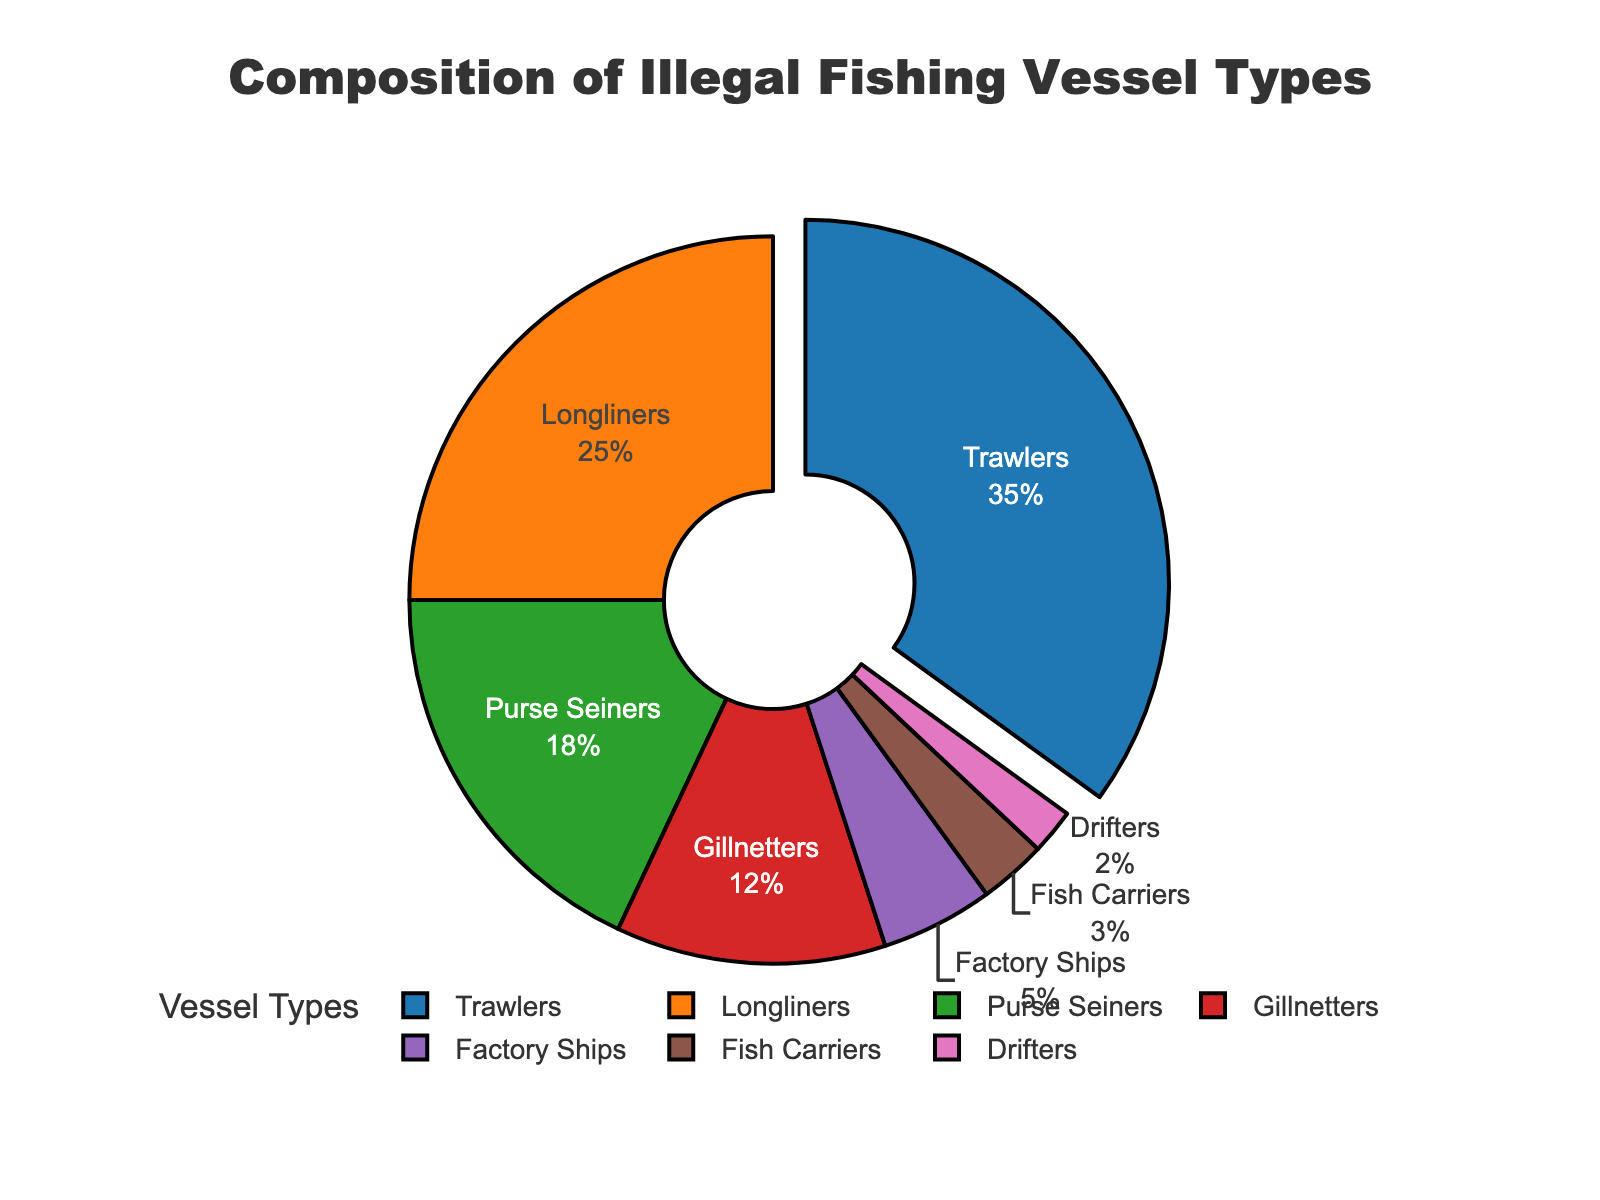What's the percentage of the most commonly encountered illegal fishing vessel type? The most commonly encountered vessel type is identified by the slice with the largest percentage. The pie chart shows the largest slice pulled out, which is 35% for Trawlers.
Answer: 35% Which types of vessels make up less than 5% each of the total illegal fishing vessels encountered? By visually inspecting the pie chart, we identify the slices that are smaller than 5%. These slices correspond to Factory Ships (5%), Fish Carriers (3%), and Drifters (2%).
Answer: Factory Ships, Fish Carriers, Drifters How does the percentage of Longliners compare to the percentage of Purse Seiners? By looking at the pie chart, we compare the slice sizes. Longliners have 25%, and Purse Seiners have 18%. Therefore, Longliners are more common.
Answer: Longliners have a higher percentage than Purse Seiners What percentage of the illegal fishing vessels are either Gillnetters or Fish Carriers? To find the total percentage for Gillnetters and Fish Carriers, we add their individual percentages: 12% (Gillnetters) + 3% (Fish Carriers) = 15%.
Answer: 15% Which vessel type is depicted with a green-colored slice in the pie chart? By referring to the provided color schema in the code, identify that the green color (#2ca02c) corresponds to Longliners.
Answer: Longliners What combined percentage of illegal fishing vessels is accounted for by Trawlers, Longliners, and Purse Seiners? To find the combined percentage, sum the individual percentages of Trawlers, Longliners, and Purse Seiners: 35% + 25% + 18% = 78%.
Answer: 78% Which vessel type has a percentage closest to 10% and what is that percentage? By comparing the percentages visually depicted in the chart, note that Gillnetters have a percentage closest to 10%, which is 12%.
Answer: Gillnetters, 12% What is the difference in the percentage of illegal fishing vessels between Trawlers and Factory Ships? Subtract the percentage of Factory Ships from the percentage of Trawlers: 35% - 5% = 30%.
Answer: 30% Which vessel type's segment is pulled out from the pie chart, and why? The segment pulled out highlights the vessel type with the highest percentage. This is the Trawlers segment, pulled out because it represents 35% of the vessels.
Answer: Trawlers Between Trawlers and Longliners, which vessel type has a greater representation percentage, and by how much? Comparing the percentages for Trawlers (35%) and Longliners (25%), Trawlers have the greater representation. The difference is 35% - 25% = 10%.
Answer: Trawlers, 10% 